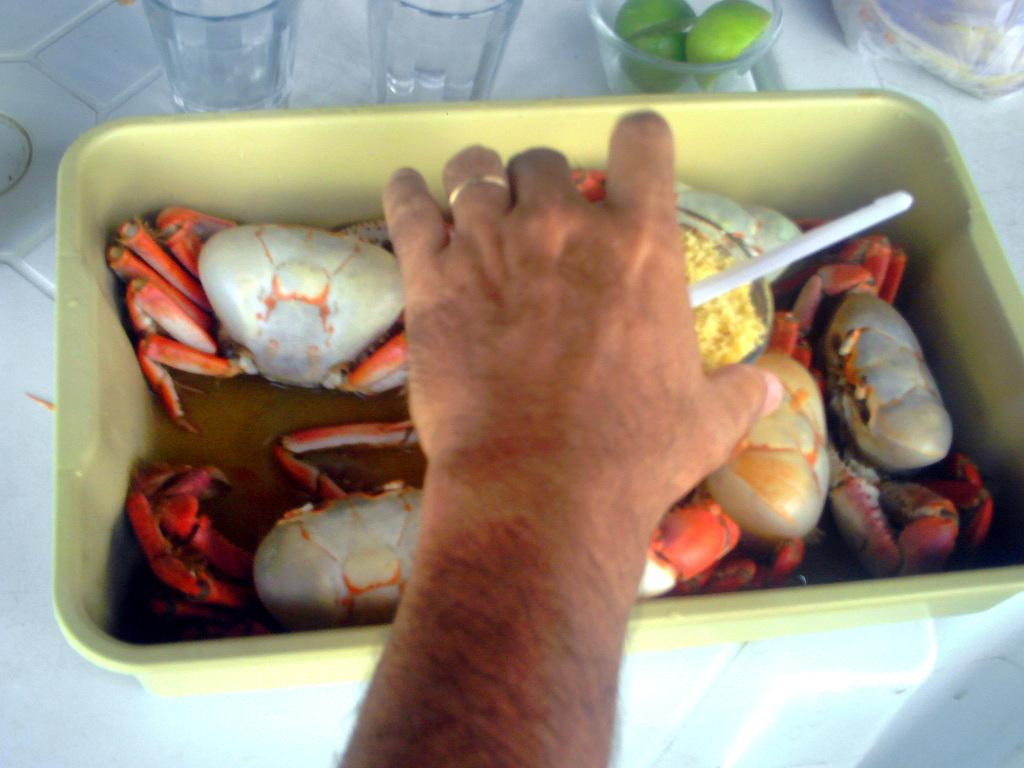What type of seafood is in the bowl in the image? There are crabs in a bowl in the image. What objects are visible behind the bowl? There are glasses behind the bowl in the image. Can you identify any human body parts in the image? Yes, a human hand is visible in the image. What type of acoustics can be heard in the background of the image? There is no information about acoustics or any sounds in the image, so it cannot be determined from the image. 